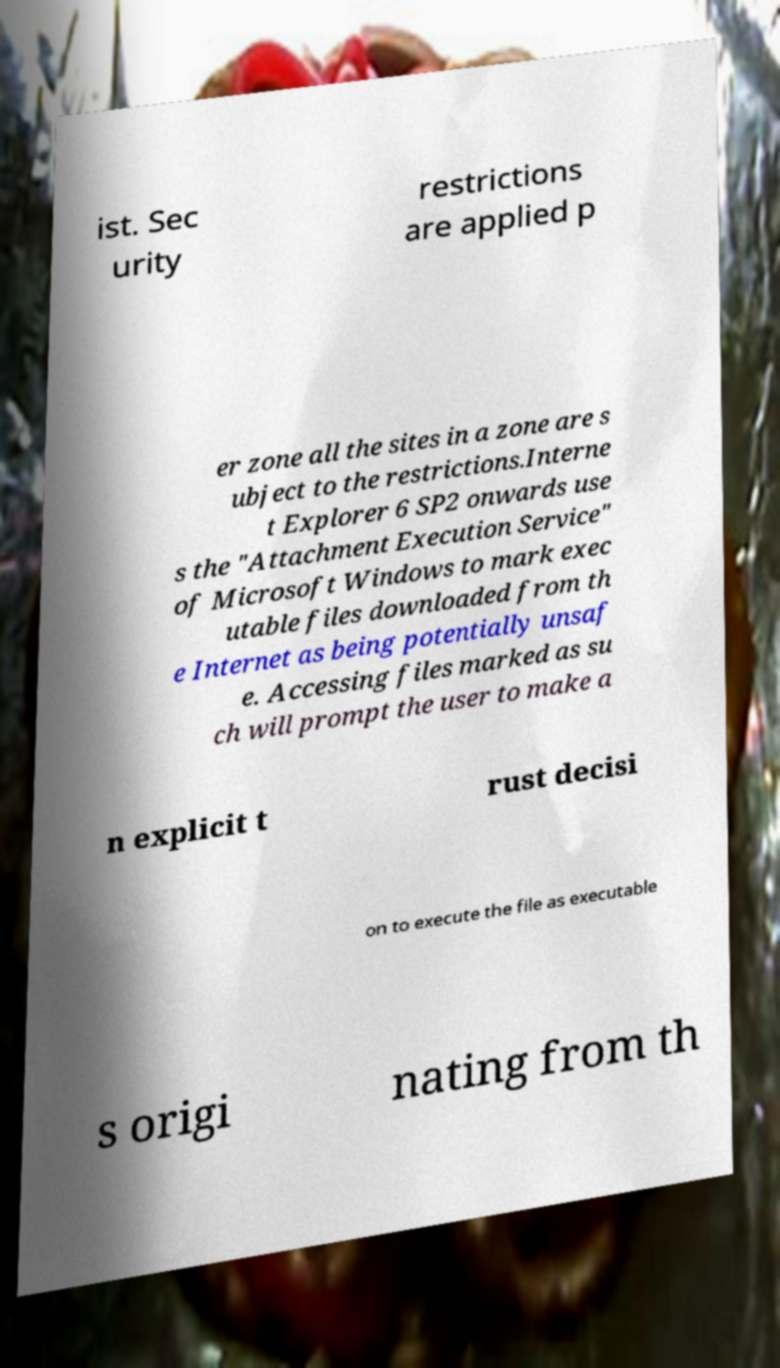For documentation purposes, I need the text within this image transcribed. Could you provide that? ist. Sec urity restrictions are applied p er zone all the sites in a zone are s ubject to the restrictions.Interne t Explorer 6 SP2 onwards use s the "Attachment Execution Service" of Microsoft Windows to mark exec utable files downloaded from th e Internet as being potentially unsaf e. Accessing files marked as su ch will prompt the user to make a n explicit t rust decisi on to execute the file as executable s origi nating from th 